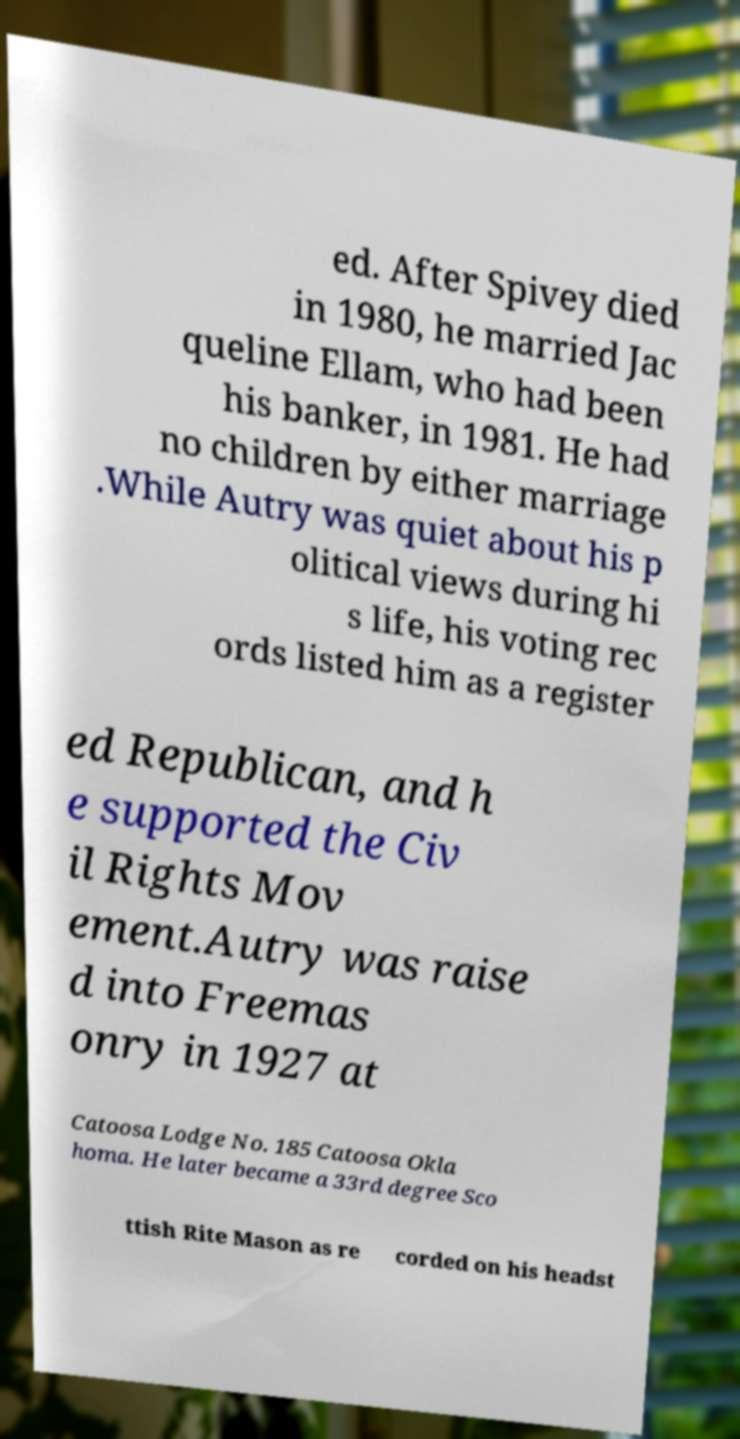I need the written content from this picture converted into text. Can you do that? ed. After Spivey died in 1980, he married Jac queline Ellam, who had been his banker, in 1981. He had no children by either marriage .While Autry was quiet about his p olitical views during hi s life, his voting rec ords listed him as a register ed Republican, and h e supported the Civ il Rights Mov ement.Autry was raise d into Freemas onry in 1927 at Catoosa Lodge No. 185 Catoosa Okla homa. He later became a 33rd degree Sco ttish Rite Mason as re corded on his headst 